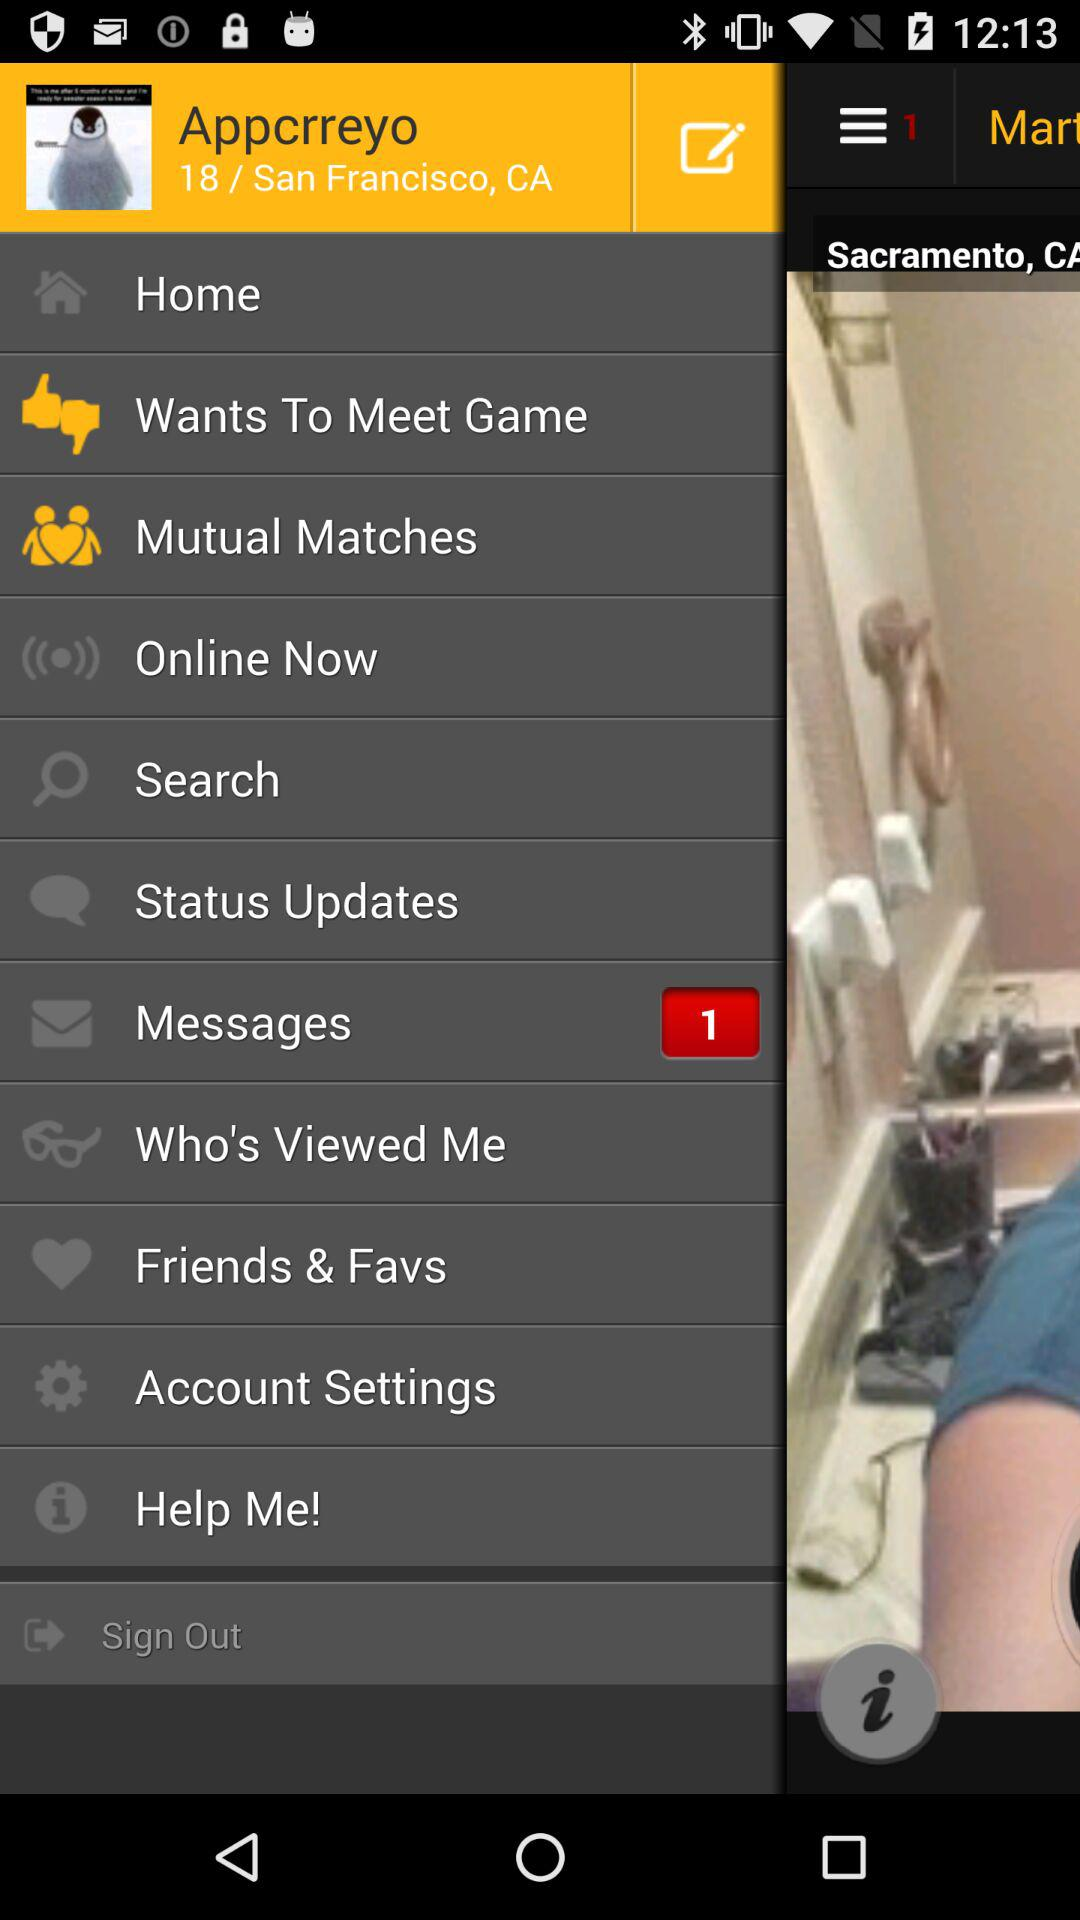What is the number of unread messages? The number of unread messages is 1. 